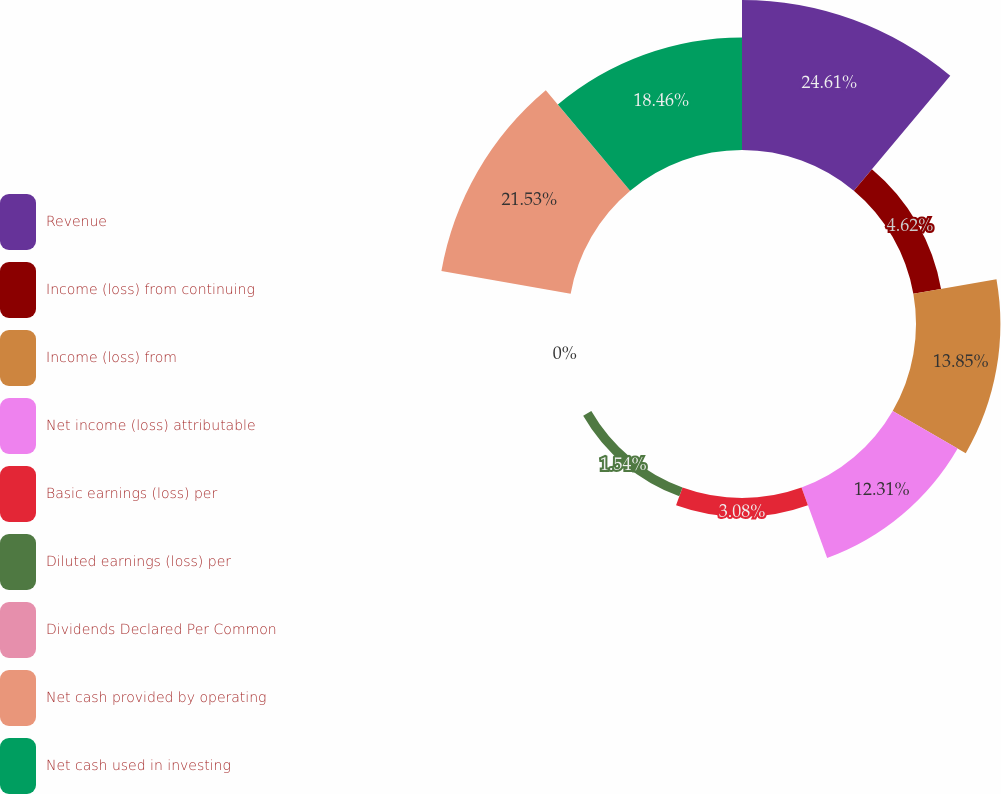Convert chart to OTSL. <chart><loc_0><loc_0><loc_500><loc_500><pie_chart><fcel>Revenue<fcel>Income (loss) from continuing<fcel>Income (loss) from<fcel>Net income (loss) attributable<fcel>Basic earnings (loss) per<fcel>Diluted earnings (loss) per<fcel>Dividends Declared Per Common<fcel>Net cash provided by operating<fcel>Net cash used in investing<nl><fcel>24.62%<fcel>4.62%<fcel>13.85%<fcel>12.31%<fcel>3.08%<fcel>1.54%<fcel>0.0%<fcel>21.54%<fcel>18.46%<nl></chart> 